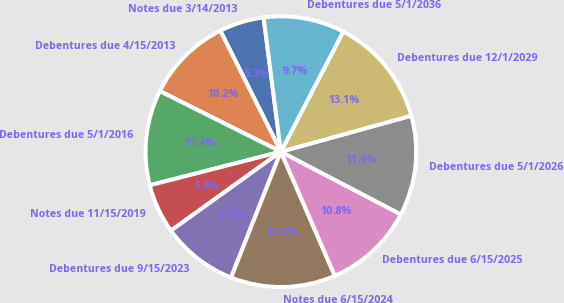Convert chart to OTSL. <chart><loc_0><loc_0><loc_500><loc_500><pie_chart><fcel>Notes due 3/14/2013<fcel>Debentures due 4/15/2013<fcel>Debentures due 5/1/2016<fcel>Notes due 11/15/2019<fcel>Debentures due 9/15/2023<fcel>Notes due 6/15/2024<fcel>Debentures due 6/15/2025<fcel>Debentures due 5/1/2026<fcel>Debentures due 12/1/2029<fcel>Debentures due 5/1/2036<nl><fcel>5.35%<fcel>10.23%<fcel>11.38%<fcel>5.92%<fcel>9.09%<fcel>12.52%<fcel>10.81%<fcel>11.95%<fcel>13.09%<fcel>9.66%<nl></chart> 